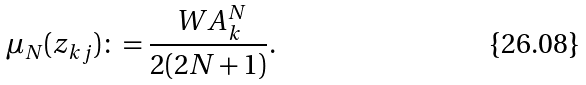Convert formula to latex. <formula><loc_0><loc_0><loc_500><loc_500>\mu _ { N } ( z _ { k j } ) \colon = \frac { \ W A _ { k } ^ { N } } { 2 ( 2 N + 1 ) } .</formula> 